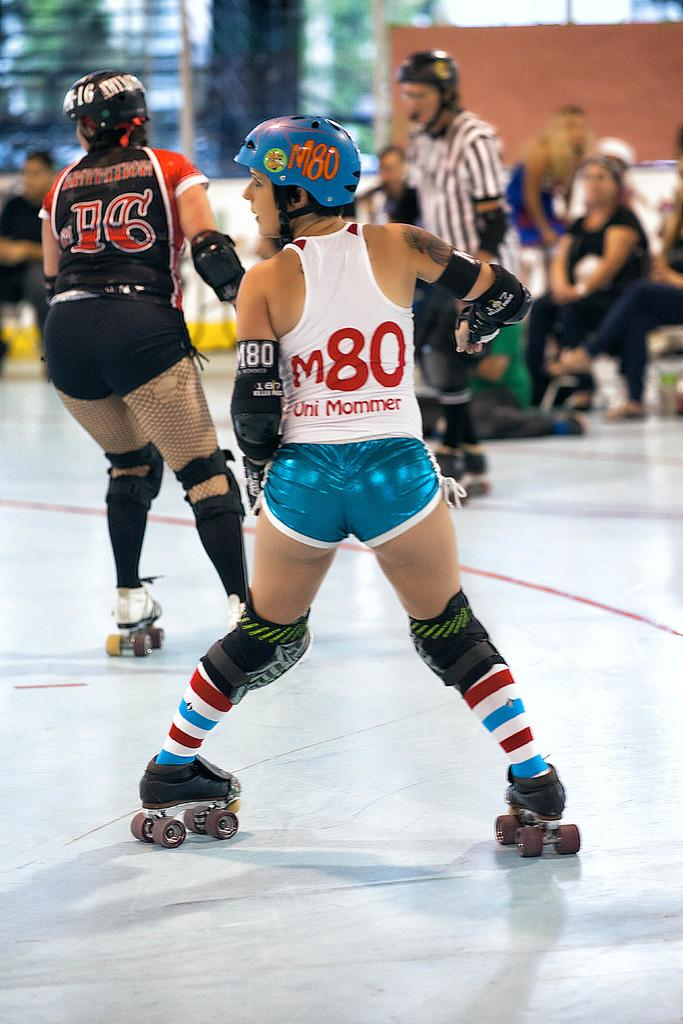Who is present in the image? There are people in the image. What type of footwear are the people wearing? The people are wearing skate shoes. What activity are the people engaged in? The people are skating on a surface. What can be observed in the background of the image? There are people seated in the background. What type of pain can be seen on the faces of the people in the image? There is no indication of pain on the faces of the people in the image; they appear to be enjoying themselves while skating. Can you see any tanks in the image? No, there are no tanks present in the image. 